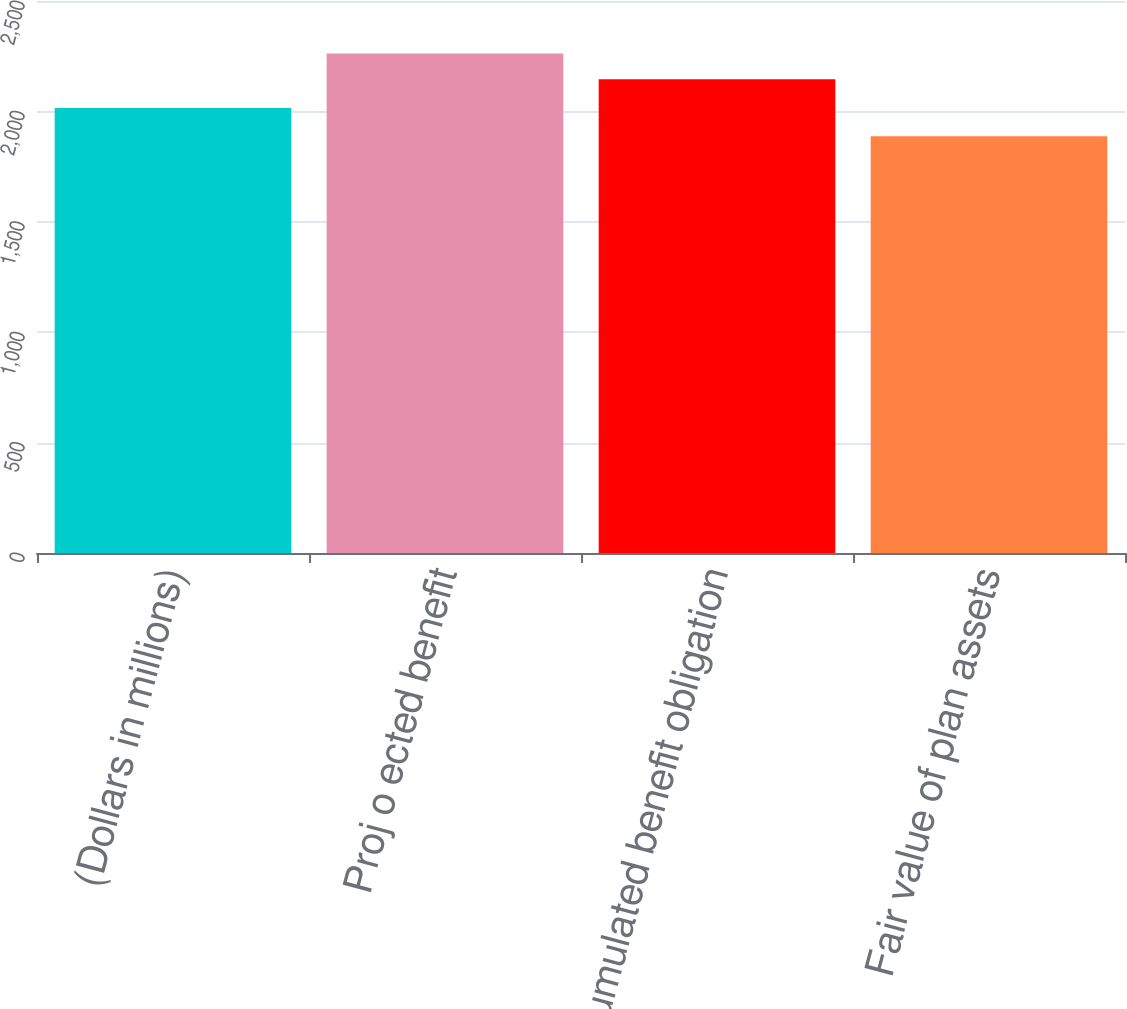Convert chart to OTSL. <chart><loc_0><loc_0><loc_500><loc_500><bar_chart><fcel>(Dollars in millions)<fcel>Proj o ected benefit<fcel>Accumulated benefit obligation<fcel>Fair value of plan assets<nl><fcel>2015<fcel>2262<fcel>2146<fcel>1887<nl></chart> 